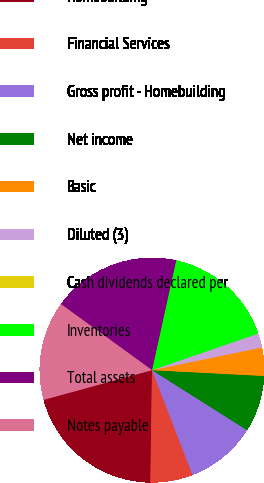<chart> <loc_0><loc_0><loc_500><loc_500><pie_chart><fcel>Homebuilding<fcel>Financial Services<fcel>Gross profit - Homebuilding<fcel>Net income<fcel>Basic<fcel>Diluted (3)<fcel>Cash dividends declared per<fcel>Inventories<fcel>Total assets<fcel>Notes payable<nl><fcel>20.51%<fcel>6.1%<fcel>10.17%<fcel>8.14%<fcel>4.07%<fcel>2.03%<fcel>0.0%<fcel>16.27%<fcel>18.47%<fcel>14.24%<nl></chart> 